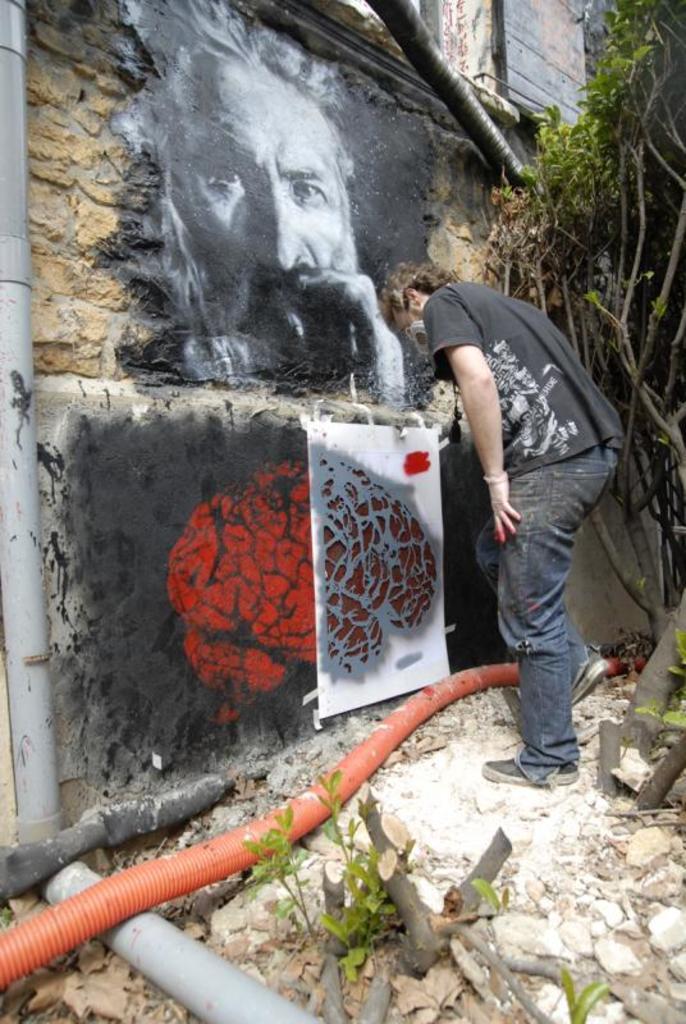How would you summarize this image in a sentence or two? In the center of the image we can see a man standing and painting on the wall. On the right side of the image we can see tree. At the bottom we can see pipes. 